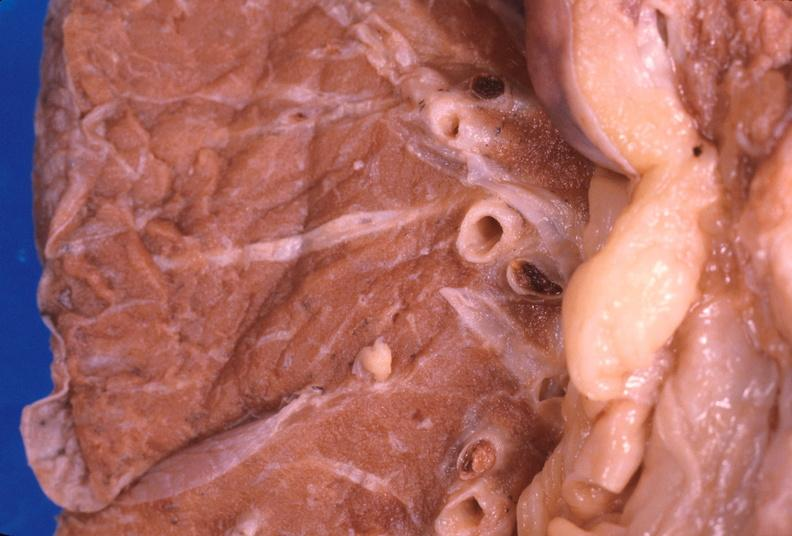what is present?
Answer the question using a single word or phrase. Respiratory 